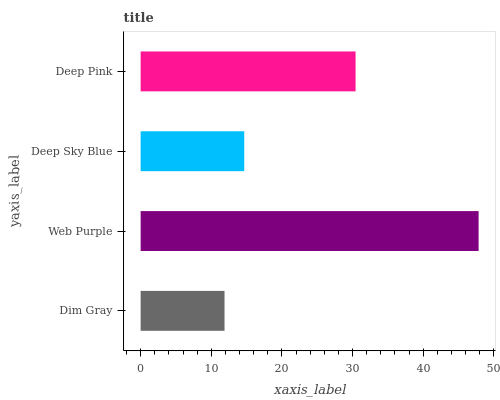Is Dim Gray the minimum?
Answer yes or no. Yes. Is Web Purple the maximum?
Answer yes or no. Yes. Is Deep Sky Blue the minimum?
Answer yes or no. No. Is Deep Sky Blue the maximum?
Answer yes or no. No. Is Web Purple greater than Deep Sky Blue?
Answer yes or no. Yes. Is Deep Sky Blue less than Web Purple?
Answer yes or no. Yes. Is Deep Sky Blue greater than Web Purple?
Answer yes or no. No. Is Web Purple less than Deep Sky Blue?
Answer yes or no. No. Is Deep Pink the high median?
Answer yes or no. Yes. Is Deep Sky Blue the low median?
Answer yes or no. Yes. Is Deep Sky Blue the high median?
Answer yes or no. No. Is Dim Gray the low median?
Answer yes or no. No. 